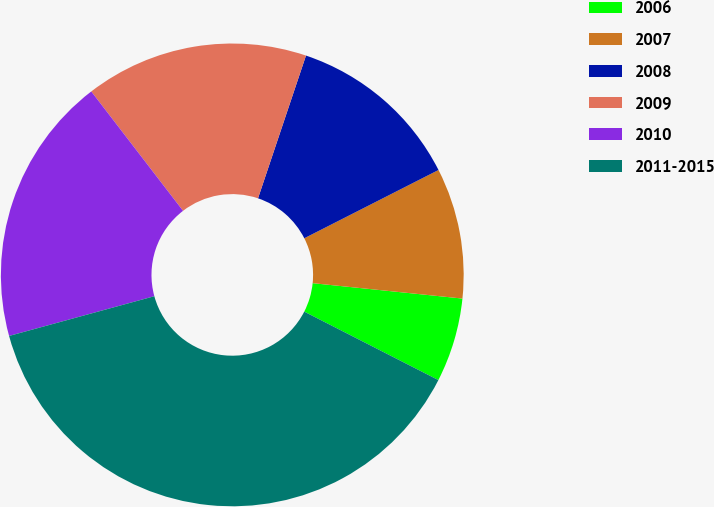<chart> <loc_0><loc_0><loc_500><loc_500><pie_chart><fcel>2006<fcel>2007<fcel>2008<fcel>2009<fcel>2010<fcel>2011-2015<nl><fcel>5.88%<fcel>9.12%<fcel>12.35%<fcel>15.59%<fcel>18.82%<fcel>38.24%<nl></chart> 